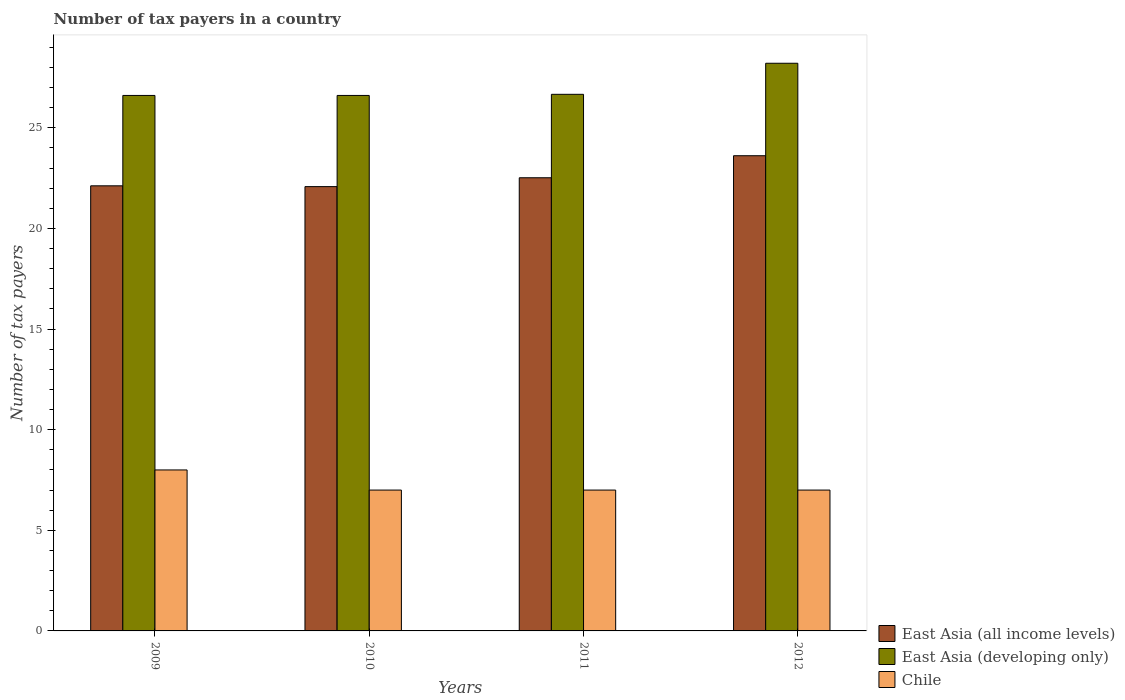How many different coloured bars are there?
Your answer should be very brief. 3. How many groups of bars are there?
Ensure brevity in your answer.  4. Are the number of bars per tick equal to the number of legend labels?
Make the answer very short. Yes. How many bars are there on the 1st tick from the left?
Your response must be concise. 3. How many bars are there on the 4th tick from the right?
Offer a very short reply. 3. What is the number of tax payers in in Chile in 2012?
Keep it short and to the point. 7. Across all years, what is the maximum number of tax payers in in Chile?
Provide a short and direct response. 8. Across all years, what is the minimum number of tax payers in in East Asia (developing only)?
Your answer should be compact. 26.61. In which year was the number of tax payers in in Chile minimum?
Provide a succinct answer. 2010. What is the total number of tax payers in in East Asia (developing only) in the graph?
Offer a terse response. 108.1. What is the difference between the number of tax payers in in Chile in 2011 and the number of tax payers in in East Asia (all income levels) in 2012?
Your response must be concise. -16.62. What is the average number of tax payers in in East Asia (developing only) per year?
Your response must be concise. 27.02. In the year 2010, what is the difference between the number of tax payers in in East Asia (all income levels) and number of tax payers in in East Asia (developing only)?
Your answer should be very brief. -4.53. In how many years, is the number of tax payers in in East Asia (developing only) greater than 14?
Provide a short and direct response. 4. What is the ratio of the number of tax payers in in East Asia (all income levels) in 2009 to that in 2012?
Your answer should be compact. 0.94. Is the number of tax payers in in Chile in 2009 less than that in 2011?
Your response must be concise. No. Is the difference between the number of tax payers in in East Asia (all income levels) in 2009 and 2011 greater than the difference between the number of tax payers in in East Asia (developing only) in 2009 and 2011?
Give a very brief answer. No. What is the difference between the highest and the second highest number of tax payers in in East Asia (all income levels)?
Offer a terse response. 1.1. What is the difference between the highest and the lowest number of tax payers in in East Asia (all income levels)?
Provide a short and direct response. 1.54. In how many years, is the number of tax payers in in Chile greater than the average number of tax payers in in Chile taken over all years?
Your response must be concise. 1. What does the 3rd bar from the left in 2010 represents?
Provide a short and direct response. Chile. What does the 1st bar from the right in 2012 represents?
Offer a very short reply. Chile. How many bars are there?
Provide a short and direct response. 12. How many years are there in the graph?
Offer a terse response. 4. Are the values on the major ticks of Y-axis written in scientific E-notation?
Provide a short and direct response. No. Does the graph contain grids?
Provide a succinct answer. No. Where does the legend appear in the graph?
Ensure brevity in your answer.  Bottom right. How are the legend labels stacked?
Your answer should be compact. Vertical. What is the title of the graph?
Provide a succinct answer. Number of tax payers in a country. Does "Moldova" appear as one of the legend labels in the graph?
Offer a terse response. No. What is the label or title of the X-axis?
Your answer should be very brief. Years. What is the label or title of the Y-axis?
Offer a terse response. Number of tax payers. What is the Number of tax payers in East Asia (all income levels) in 2009?
Your response must be concise. 22.12. What is the Number of tax payers of East Asia (developing only) in 2009?
Ensure brevity in your answer.  26.61. What is the Number of tax payers of Chile in 2009?
Make the answer very short. 8. What is the Number of tax payers in East Asia (all income levels) in 2010?
Keep it short and to the point. 22.08. What is the Number of tax payers of East Asia (developing only) in 2010?
Offer a very short reply. 26.61. What is the Number of tax payers of East Asia (all income levels) in 2011?
Give a very brief answer. 22.52. What is the Number of tax payers of East Asia (developing only) in 2011?
Ensure brevity in your answer.  26.67. What is the Number of tax payers of East Asia (all income levels) in 2012?
Provide a succinct answer. 23.62. What is the Number of tax payers in East Asia (developing only) in 2012?
Offer a terse response. 28.21. Across all years, what is the maximum Number of tax payers in East Asia (all income levels)?
Offer a very short reply. 23.62. Across all years, what is the maximum Number of tax payers in East Asia (developing only)?
Ensure brevity in your answer.  28.21. Across all years, what is the minimum Number of tax payers of East Asia (all income levels)?
Your answer should be very brief. 22.08. Across all years, what is the minimum Number of tax payers of East Asia (developing only)?
Offer a terse response. 26.61. Across all years, what is the minimum Number of tax payers of Chile?
Your response must be concise. 7. What is the total Number of tax payers in East Asia (all income levels) in the graph?
Your response must be concise. 90.34. What is the total Number of tax payers of East Asia (developing only) in the graph?
Keep it short and to the point. 108.1. What is the difference between the Number of tax payers in Chile in 2009 and that in 2010?
Offer a terse response. 1. What is the difference between the Number of tax payers in East Asia (all income levels) in 2009 and that in 2011?
Your answer should be compact. -0.4. What is the difference between the Number of tax payers in East Asia (developing only) in 2009 and that in 2011?
Provide a short and direct response. -0.06. What is the difference between the Number of tax payers of East Asia (all income levels) in 2009 and that in 2012?
Provide a short and direct response. -1.5. What is the difference between the Number of tax payers in East Asia (developing only) in 2009 and that in 2012?
Keep it short and to the point. -1.6. What is the difference between the Number of tax payers of Chile in 2009 and that in 2012?
Give a very brief answer. 1. What is the difference between the Number of tax payers of East Asia (all income levels) in 2010 and that in 2011?
Make the answer very short. -0.44. What is the difference between the Number of tax payers in East Asia (developing only) in 2010 and that in 2011?
Your answer should be very brief. -0.06. What is the difference between the Number of tax payers of Chile in 2010 and that in 2011?
Your answer should be very brief. 0. What is the difference between the Number of tax payers of East Asia (all income levels) in 2010 and that in 2012?
Provide a succinct answer. -1.54. What is the difference between the Number of tax payers in East Asia (developing only) in 2010 and that in 2012?
Your answer should be very brief. -1.6. What is the difference between the Number of tax payers of East Asia (all income levels) in 2011 and that in 2012?
Keep it short and to the point. -1.1. What is the difference between the Number of tax payers in East Asia (developing only) in 2011 and that in 2012?
Make the answer very short. -1.54. What is the difference between the Number of tax payers in Chile in 2011 and that in 2012?
Offer a terse response. 0. What is the difference between the Number of tax payers of East Asia (all income levels) in 2009 and the Number of tax payers of East Asia (developing only) in 2010?
Your response must be concise. -4.49. What is the difference between the Number of tax payers in East Asia (all income levels) in 2009 and the Number of tax payers in Chile in 2010?
Your response must be concise. 15.12. What is the difference between the Number of tax payers of East Asia (developing only) in 2009 and the Number of tax payers of Chile in 2010?
Keep it short and to the point. 19.61. What is the difference between the Number of tax payers of East Asia (all income levels) in 2009 and the Number of tax payers of East Asia (developing only) in 2011?
Your answer should be very brief. -4.55. What is the difference between the Number of tax payers in East Asia (all income levels) in 2009 and the Number of tax payers in Chile in 2011?
Provide a succinct answer. 15.12. What is the difference between the Number of tax payers in East Asia (developing only) in 2009 and the Number of tax payers in Chile in 2011?
Ensure brevity in your answer.  19.61. What is the difference between the Number of tax payers of East Asia (all income levels) in 2009 and the Number of tax payers of East Asia (developing only) in 2012?
Your answer should be very brief. -6.09. What is the difference between the Number of tax payers in East Asia (all income levels) in 2009 and the Number of tax payers in Chile in 2012?
Make the answer very short. 15.12. What is the difference between the Number of tax payers of East Asia (developing only) in 2009 and the Number of tax payers of Chile in 2012?
Give a very brief answer. 19.61. What is the difference between the Number of tax payers in East Asia (all income levels) in 2010 and the Number of tax payers in East Asia (developing only) in 2011?
Provide a short and direct response. -4.59. What is the difference between the Number of tax payers in East Asia (all income levels) in 2010 and the Number of tax payers in Chile in 2011?
Ensure brevity in your answer.  15.08. What is the difference between the Number of tax payers in East Asia (developing only) in 2010 and the Number of tax payers in Chile in 2011?
Offer a very short reply. 19.61. What is the difference between the Number of tax payers in East Asia (all income levels) in 2010 and the Number of tax payers in East Asia (developing only) in 2012?
Make the answer very short. -6.13. What is the difference between the Number of tax payers in East Asia (all income levels) in 2010 and the Number of tax payers in Chile in 2012?
Keep it short and to the point. 15.08. What is the difference between the Number of tax payers in East Asia (developing only) in 2010 and the Number of tax payers in Chile in 2012?
Provide a succinct answer. 19.61. What is the difference between the Number of tax payers of East Asia (all income levels) in 2011 and the Number of tax payers of East Asia (developing only) in 2012?
Keep it short and to the point. -5.69. What is the difference between the Number of tax payers of East Asia (all income levels) in 2011 and the Number of tax payers of Chile in 2012?
Make the answer very short. 15.52. What is the difference between the Number of tax payers of East Asia (developing only) in 2011 and the Number of tax payers of Chile in 2012?
Provide a succinct answer. 19.67. What is the average Number of tax payers of East Asia (all income levels) per year?
Offer a terse response. 22.58. What is the average Number of tax payers in East Asia (developing only) per year?
Keep it short and to the point. 27.02. What is the average Number of tax payers of Chile per year?
Offer a terse response. 7.25. In the year 2009, what is the difference between the Number of tax payers in East Asia (all income levels) and Number of tax payers in East Asia (developing only)?
Offer a very short reply. -4.49. In the year 2009, what is the difference between the Number of tax payers of East Asia (all income levels) and Number of tax payers of Chile?
Make the answer very short. 14.12. In the year 2009, what is the difference between the Number of tax payers in East Asia (developing only) and Number of tax payers in Chile?
Provide a succinct answer. 18.61. In the year 2010, what is the difference between the Number of tax payers in East Asia (all income levels) and Number of tax payers in East Asia (developing only)?
Give a very brief answer. -4.53. In the year 2010, what is the difference between the Number of tax payers of East Asia (all income levels) and Number of tax payers of Chile?
Offer a very short reply. 15.08. In the year 2010, what is the difference between the Number of tax payers of East Asia (developing only) and Number of tax payers of Chile?
Your answer should be very brief. 19.61. In the year 2011, what is the difference between the Number of tax payers in East Asia (all income levels) and Number of tax payers in East Asia (developing only)?
Your answer should be compact. -4.15. In the year 2011, what is the difference between the Number of tax payers of East Asia (all income levels) and Number of tax payers of Chile?
Offer a terse response. 15.52. In the year 2011, what is the difference between the Number of tax payers of East Asia (developing only) and Number of tax payers of Chile?
Give a very brief answer. 19.67. In the year 2012, what is the difference between the Number of tax payers in East Asia (all income levels) and Number of tax payers in East Asia (developing only)?
Make the answer very short. -4.6. In the year 2012, what is the difference between the Number of tax payers in East Asia (all income levels) and Number of tax payers in Chile?
Give a very brief answer. 16.62. In the year 2012, what is the difference between the Number of tax payers of East Asia (developing only) and Number of tax payers of Chile?
Your answer should be compact. 21.21. What is the ratio of the Number of tax payers in East Asia (developing only) in 2009 to that in 2010?
Your answer should be compact. 1. What is the ratio of the Number of tax payers in East Asia (all income levels) in 2009 to that in 2011?
Provide a short and direct response. 0.98. What is the ratio of the Number of tax payers of Chile in 2009 to that in 2011?
Offer a terse response. 1.14. What is the ratio of the Number of tax payers of East Asia (all income levels) in 2009 to that in 2012?
Ensure brevity in your answer.  0.94. What is the ratio of the Number of tax payers of East Asia (developing only) in 2009 to that in 2012?
Your answer should be very brief. 0.94. What is the ratio of the Number of tax payers in East Asia (all income levels) in 2010 to that in 2011?
Ensure brevity in your answer.  0.98. What is the ratio of the Number of tax payers of Chile in 2010 to that in 2011?
Provide a short and direct response. 1. What is the ratio of the Number of tax payers in East Asia (all income levels) in 2010 to that in 2012?
Offer a terse response. 0.94. What is the ratio of the Number of tax payers of East Asia (developing only) in 2010 to that in 2012?
Offer a very short reply. 0.94. What is the ratio of the Number of tax payers of East Asia (all income levels) in 2011 to that in 2012?
Offer a terse response. 0.95. What is the ratio of the Number of tax payers of East Asia (developing only) in 2011 to that in 2012?
Your answer should be very brief. 0.95. What is the difference between the highest and the second highest Number of tax payers of East Asia (all income levels)?
Your response must be concise. 1.1. What is the difference between the highest and the second highest Number of tax payers in East Asia (developing only)?
Provide a short and direct response. 1.54. What is the difference between the highest and the second highest Number of tax payers of Chile?
Your answer should be compact. 1. What is the difference between the highest and the lowest Number of tax payers of East Asia (all income levels)?
Ensure brevity in your answer.  1.54. What is the difference between the highest and the lowest Number of tax payers in East Asia (developing only)?
Make the answer very short. 1.6. What is the difference between the highest and the lowest Number of tax payers of Chile?
Offer a terse response. 1. 